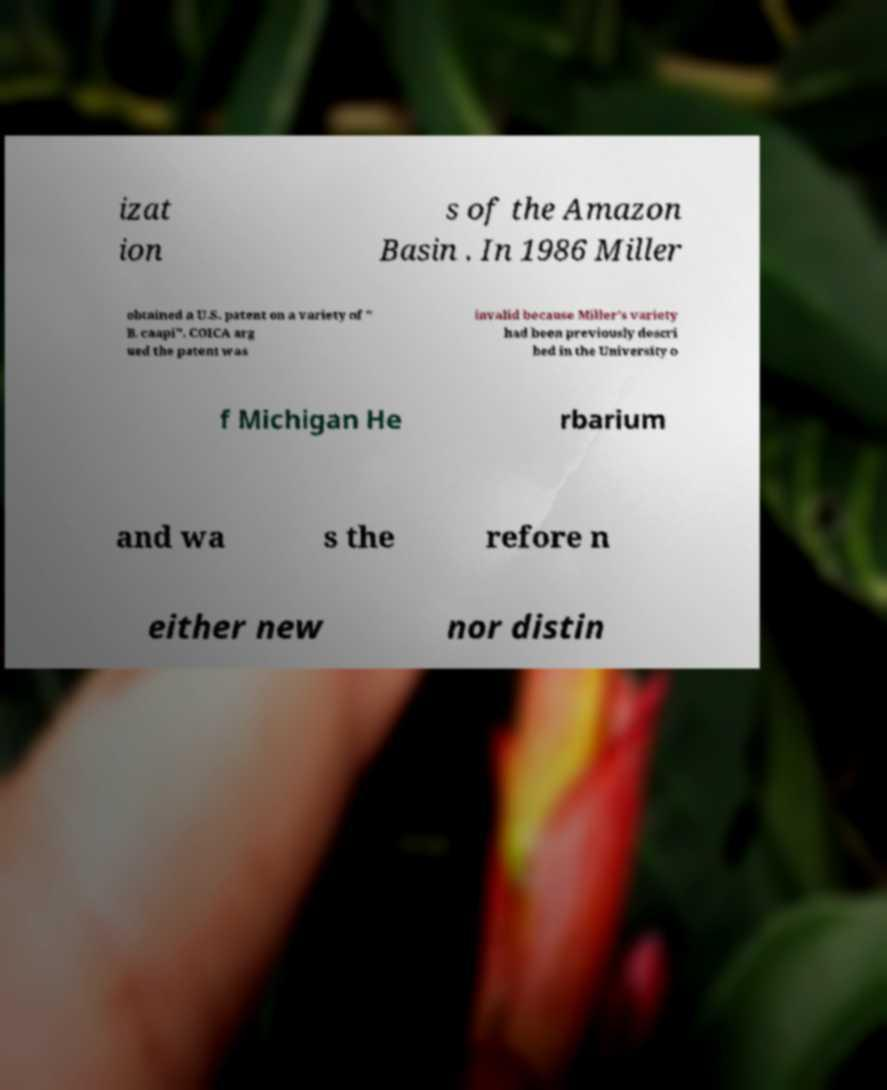Please identify and transcribe the text found in this image. izat ion s of the Amazon Basin . In 1986 Miller obtained a U.S. patent on a variety of " B. caapi". COICA arg ued the patent was invalid because Miller's variety had been previously descri bed in the University o f Michigan He rbarium and wa s the refore n either new nor distin 